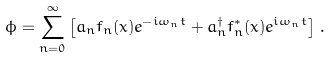<formula> <loc_0><loc_0><loc_500><loc_500>\phi = \sum _ { n = 0 } ^ { \infty } \left [ a _ { n } f _ { n } ( x ) e ^ { - i \omega _ { n } t } + a ^ { \dagger } _ { n } f ^ { * } _ { n } ( x ) e ^ { i \omega _ { n } t } \right ] \, .</formula> 